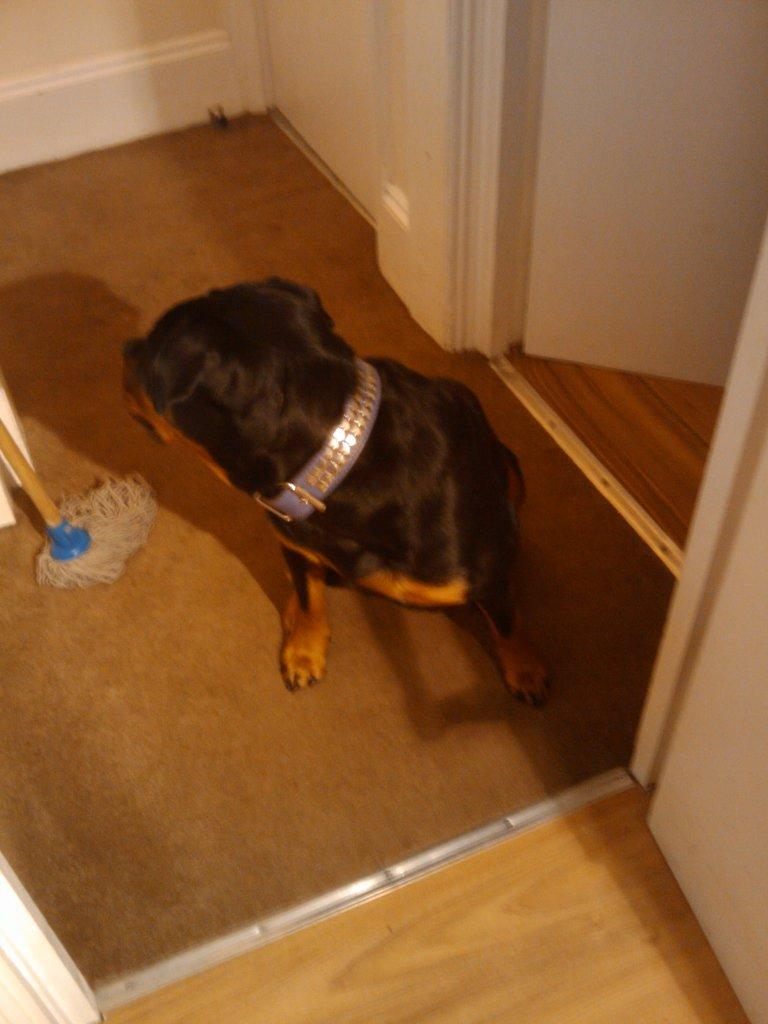What type of animal can be seen in the image? There is a dog in the image. What object is on the floor in the image? There is a mop stick on the floor in the image. What type of structure is visible in the image? There are walls visible in the image. Can you describe any other objects in the image? There are some unspecified objects in the image. What color is the spot on the dog's fur in the image? There is no spot visible on the dog's fur in the image. How many units are present in the image? The term "unit" is not mentioned in the provided facts, and therefore cannot be answered definitively. 